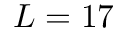<formula> <loc_0><loc_0><loc_500><loc_500>L = 1 7</formula> 